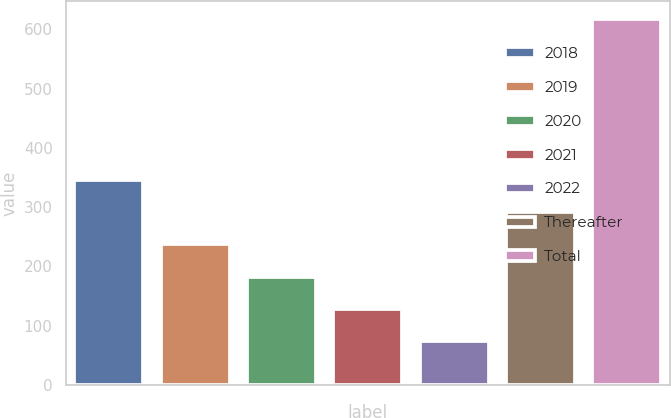<chart> <loc_0><loc_0><loc_500><loc_500><bar_chart><fcel>2018<fcel>2019<fcel>2020<fcel>2021<fcel>2022<fcel>Thereafter<fcel>Total<nl><fcel>345.5<fcel>236.9<fcel>182.6<fcel>128.3<fcel>74<fcel>291.2<fcel>617<nl></chart> 